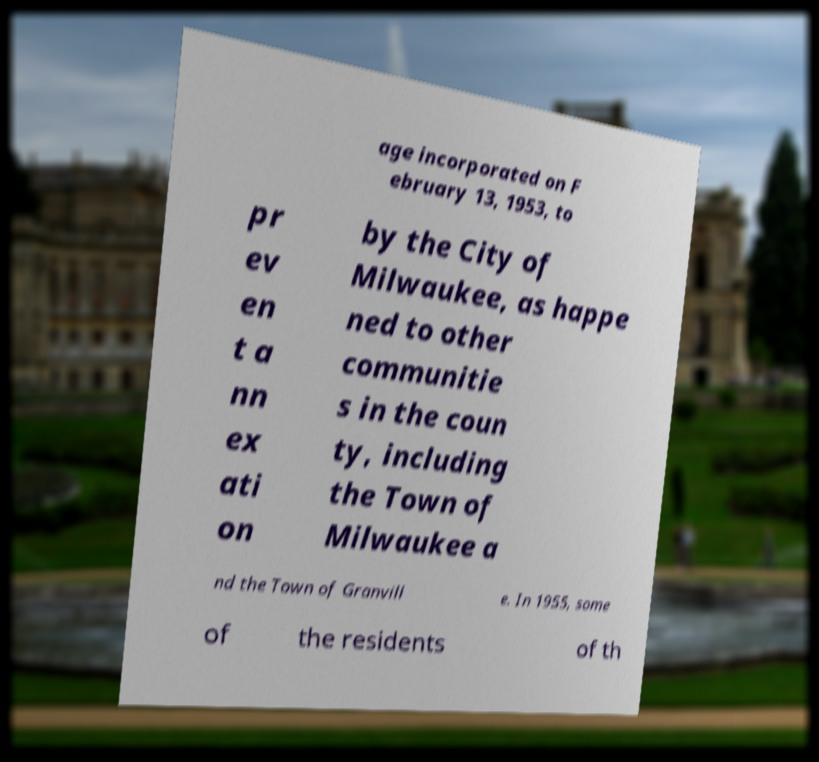Please read and relay the text visible in this image. What does it say? age incorporated on F ebruary 13, 1953, to pr ev en t a nn ex ati on by the City of Milwaukee, as happe ned to other communitie s in the coun ty, including the Town of Milwaukee a nd the Town of Granvill e. In 1955, some of the residents of th 